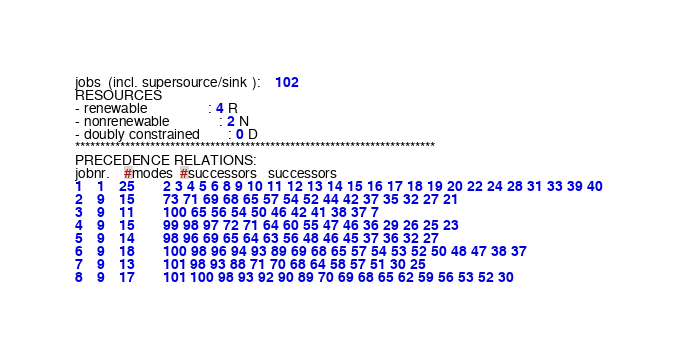<code> <loc_0><loc_0><loc_500><loc_500><_ObjectiveC_>jobs  (incl. supersource/sink ):	102
RESOURCES
- renewable                 : 4 R
- nonrenewable              : 2 N
- doubly constrained        : 0 D
************************************************************************
PRECEDENCE RELATIONS:
jobnr.    #modes  #successors   successors
1	1	25		2 3 4 5 6 8 9 10 11 12 13 14 15 16 17 18 19 20 22 24 28 31 33 39 40 
2	9	15		73 71 69 68 65 57 54 52 44 42 37 35 32 27 21 
3	9	11		100 65 56 54 50 46 42 41 38 37 7 
4	9	15		99 98 97 72 71 64 60 55 47 46 36 29 26 25 23 
5	9	14		98 96 69 65 64 63 56 48 46 45 37 36 32 27 
6	9	18		100 98 96 94 93 89 69 68 65 57 54 53 52 50 48 47 38 37 
7	9	13		101 98 93 88 71 70 68 64 58 57 51 30 25 
8	9	17		101 100 98 93 92 90 89 70 69 68 65 62 59 56 53 52 30 </code> 